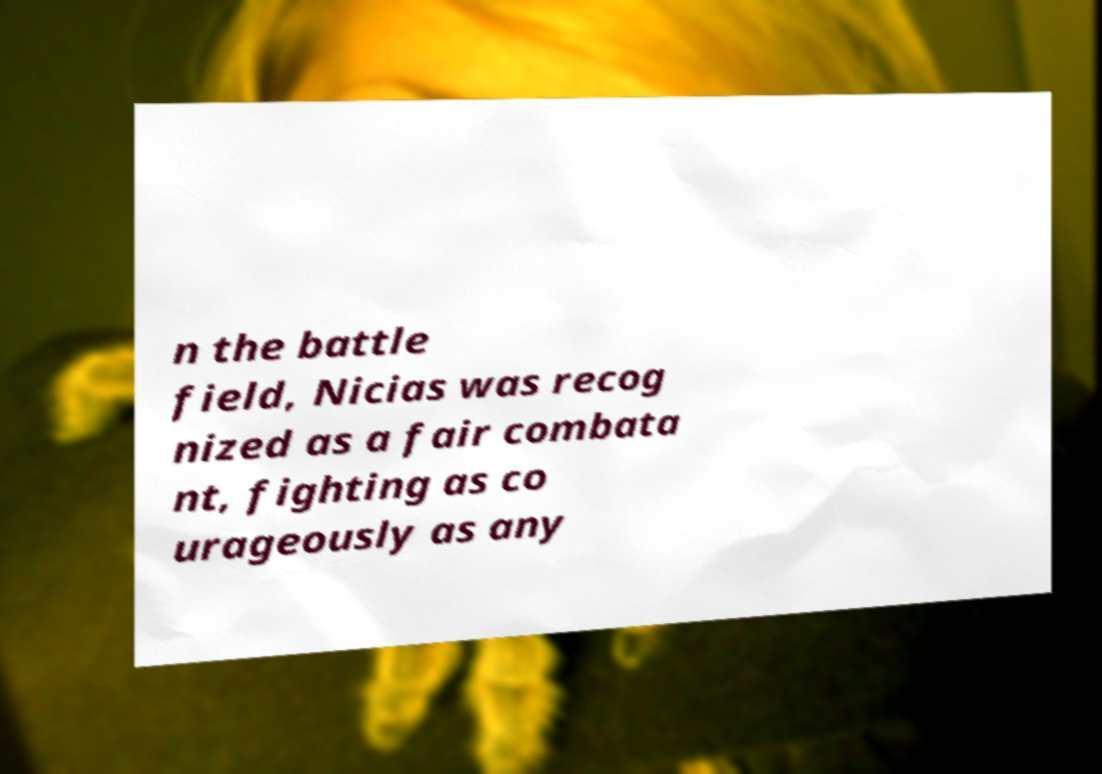Please read and relay the text visible in this image. What does it say? n the battle field, Nicias was recog nized as a fair combata nt, fighting as co urageously as any 